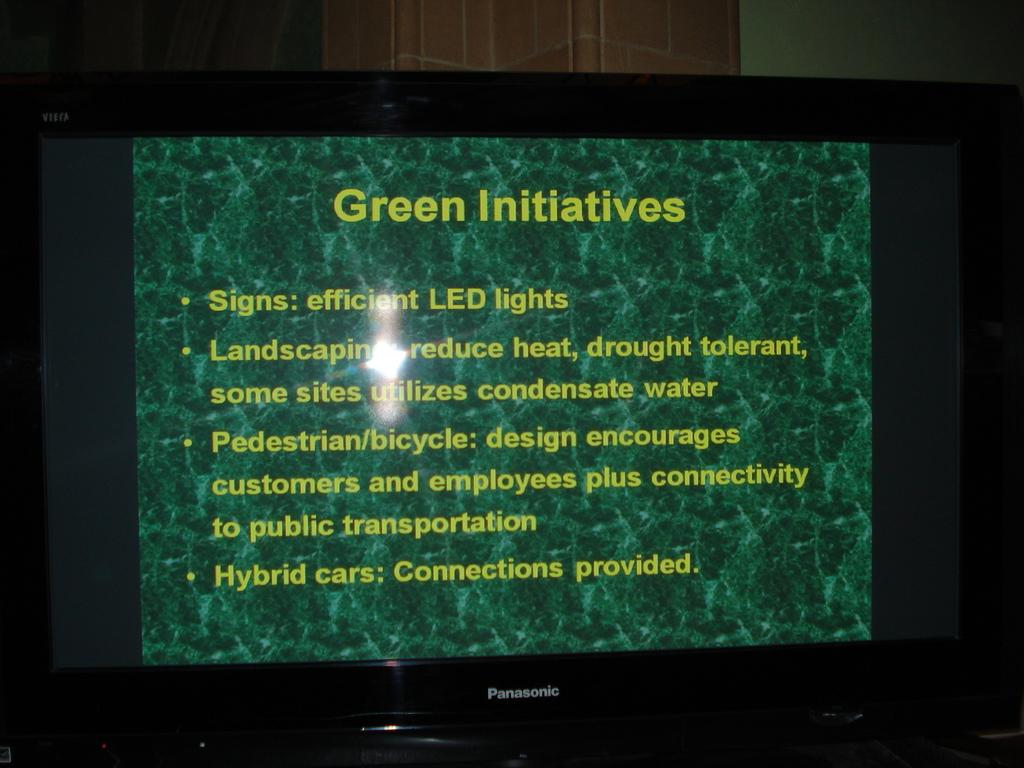<image>
Write a terse but informative summary of the picture. Panasonic monitor or tv displaying green initiatives such as LED lights. 